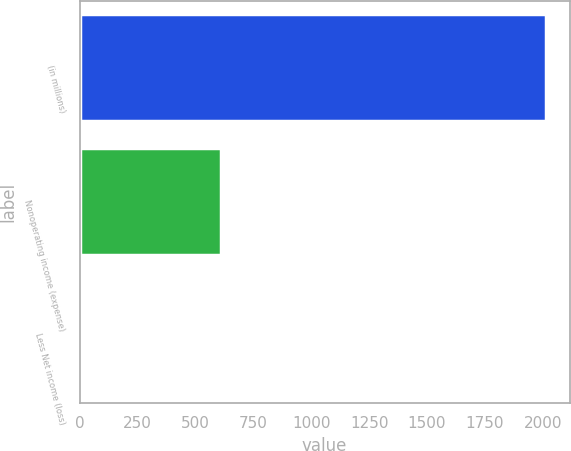<chart> <loc_0><loc_0><loc_500><loc_500><bar_chart><fcel>(in millions)<fcel>Nonoperating income (expense)<fcel>Less Net income (loss)<nl><fcel>2015<fcel>609.4<fcel>7<nl></chart> 